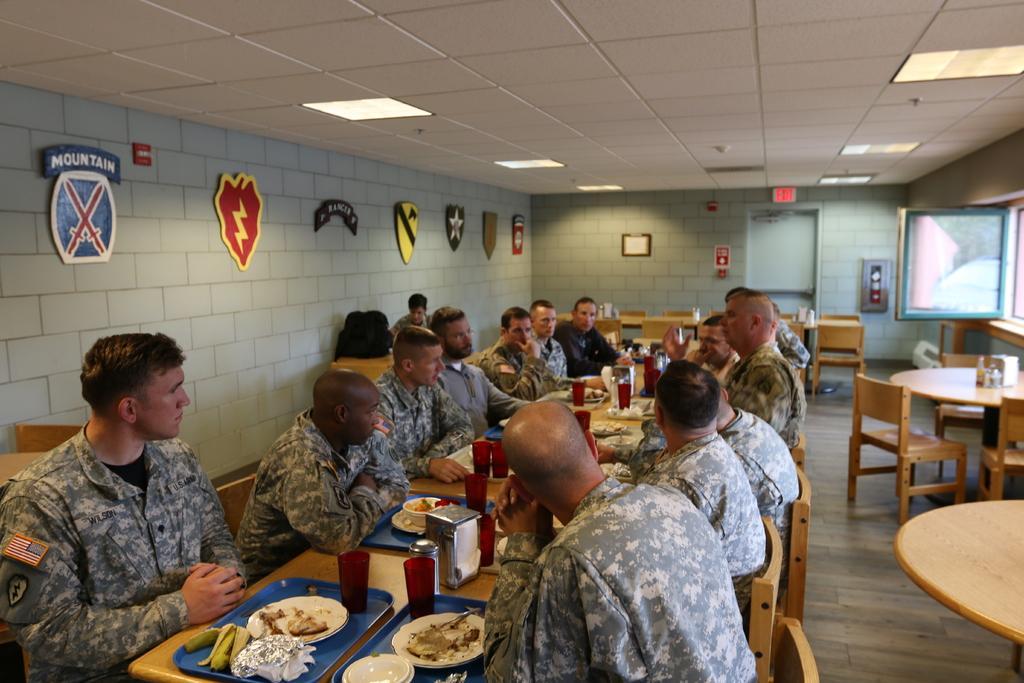Could you give a brief overview of what you see in this image? These persons are sitting beside this table. On this table there is a tray, plates, glasses, bowls and food. Different type of shields on wall. Most of the persons wore military dress. Here we can able to see chairs and tables. On this table there is a bag. A light is attached to the ceiling. 